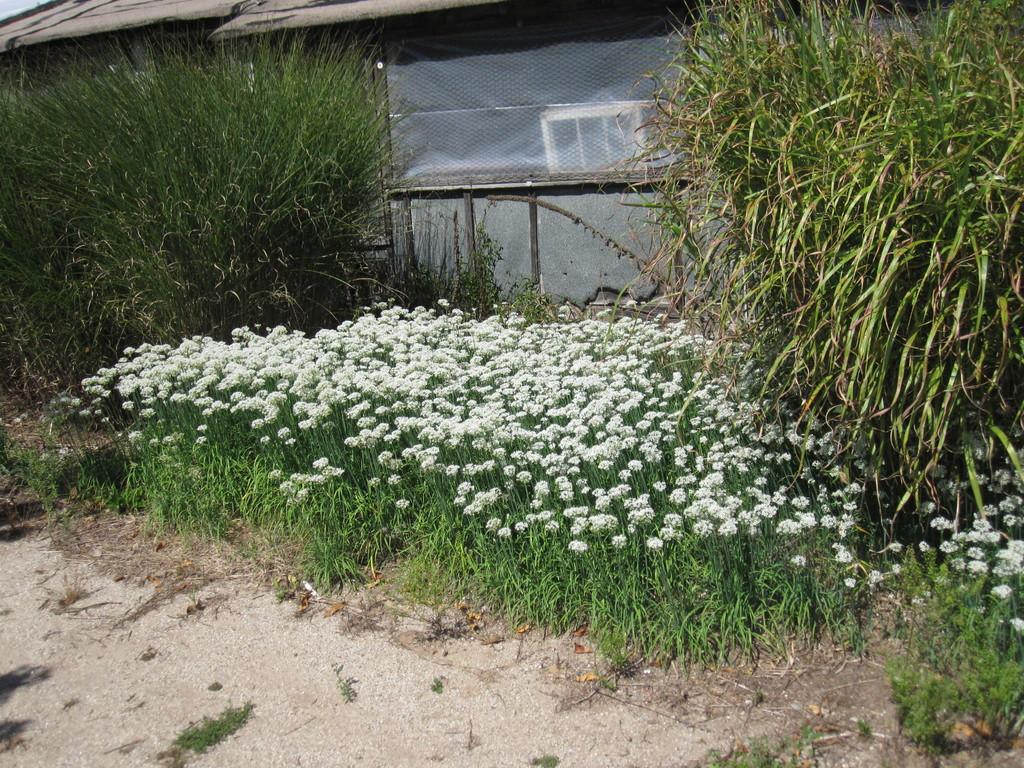What type of structure is visible in the image? There is a house in the image. What else can be seen in the image besides the house? There are many plants in the image. Can you describe the plants in the image? The plants in the image have flowers on them. What type of carriage is parked in front of the house in the image? There is no carriage present in the image; it only shows a house and plants with flowers. 